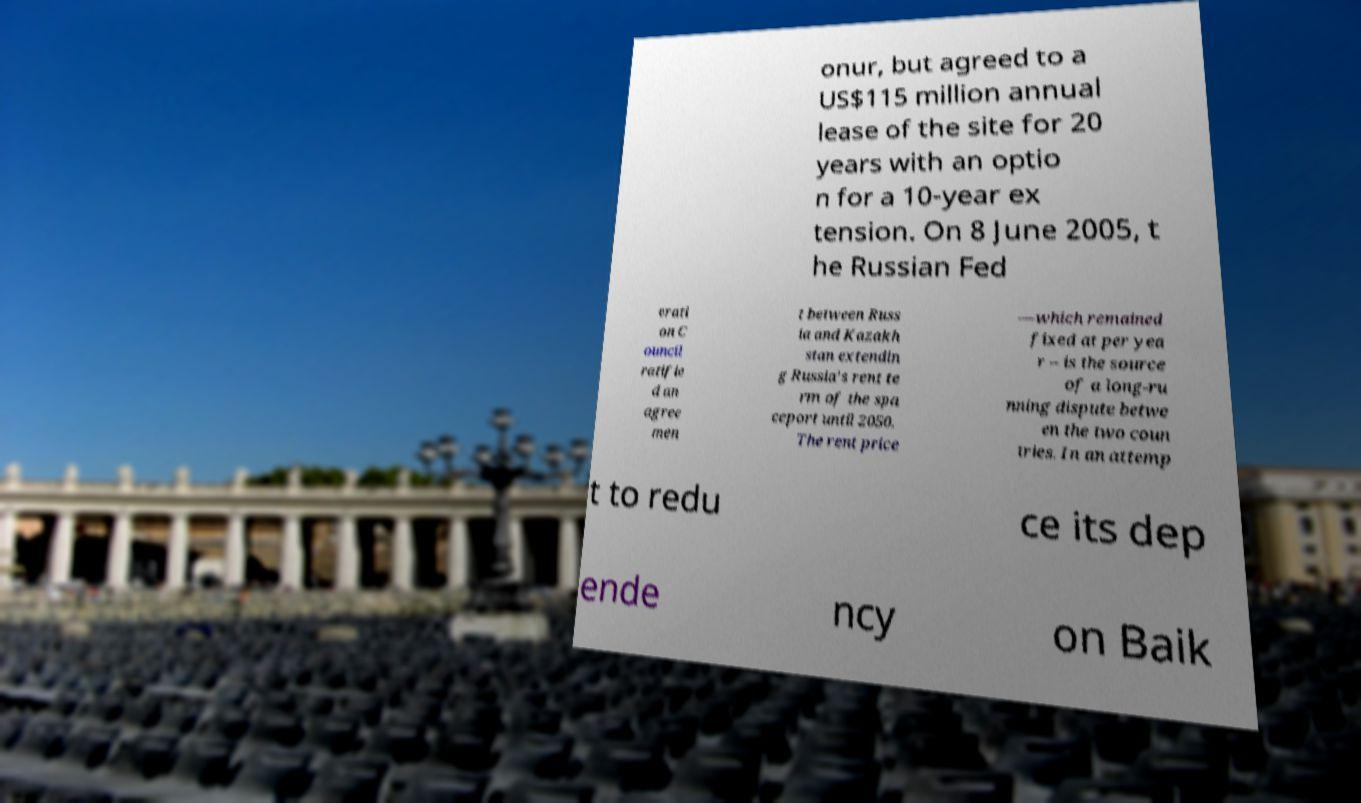Can you read and provide the text displayed in the image?This photo seems to have some interesting text. Can you extract and type it out for me? onur, but agreed to a US$115 million annual lease of the site for 20 years with an optio n for a 10-year ex tension. On 8 June 2005, t he Russian Fed erati on C ouncil ratifie d an agree men t between Russ ia and Kazakh stan extendin g Russia's rent te rm of the spa ceport until 2050. The rent price —which remained fixed at per yea r – is the source of a long-ru nning dispute betwe en the two coun tries. In an attemp t to redu ce its dep ende ncy on Baik 